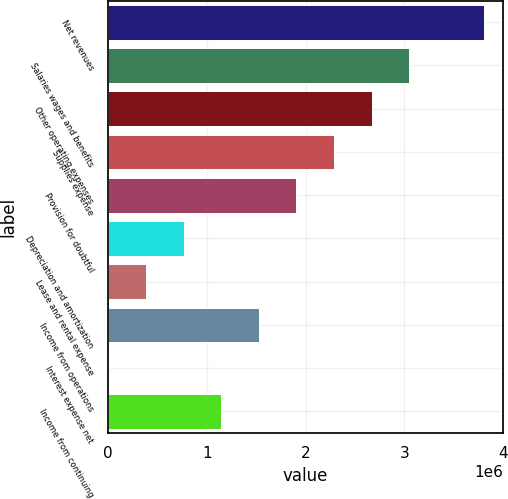<chart> <loc_0><loc_0><loc_500><loc_500><bar_chart><fcel>Net revenues<fcel>Salaries wages and benefits<fcel>Other operating expenses<fcel>Supplies expense<fcel>Provision for doubtful<fcel>Depreciation and amortization<fcel>Lease and rental expense<fcel>Income from operations<fcel>Interest expense net<fcel>Income from continuing<nl><fcel>3.81083e+06<fcel>3.04941e+06<fcel>2.6687e+06<fcel>2.28798e+06<fcel>1.90727e+06<fcel>765141<fcel>384430<fcel>1.52656e+06<fcel>3719<fcel>1.14585e+06<nl></chart> 